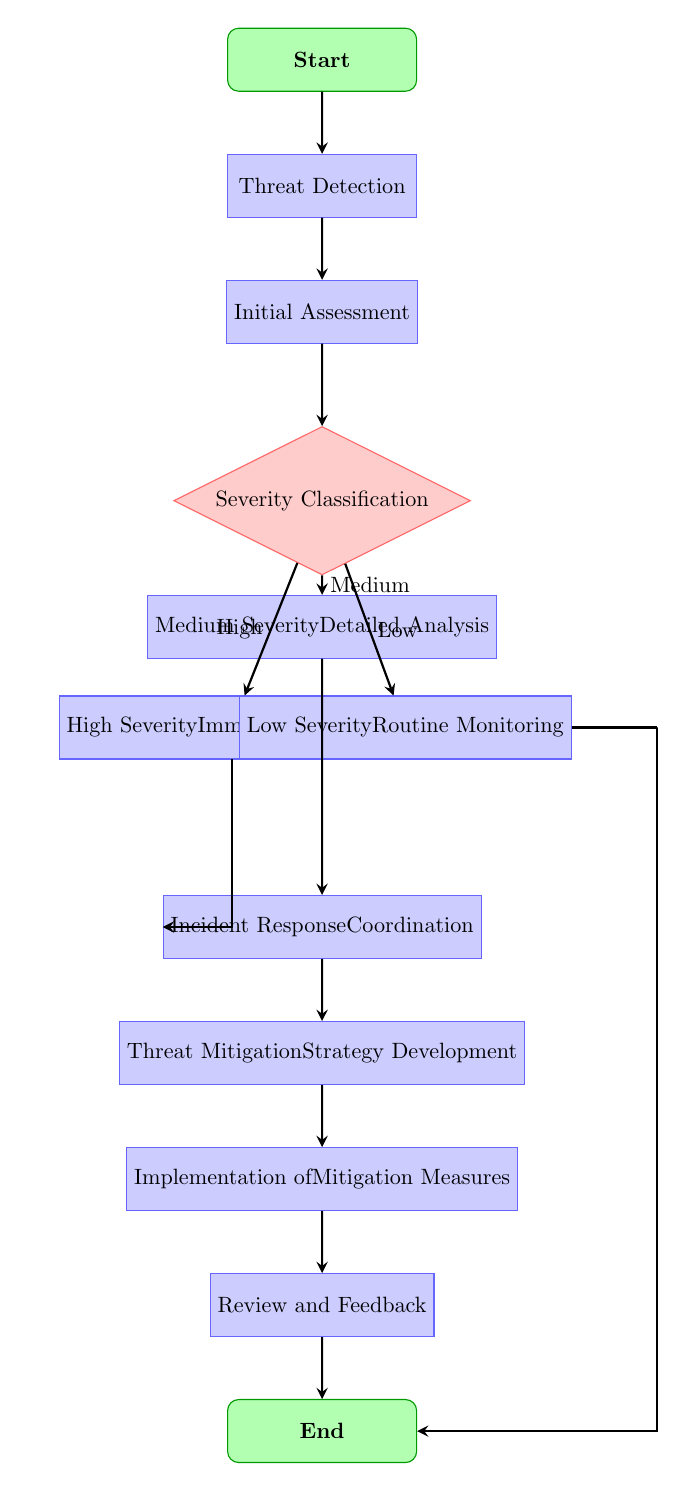What is the first step in the workflow? The first step in the workflow is labeled as “Start,” indicating the initiation of the process. This is the topmost node in the flow chart.
Answer: Start How many decision nodes are in the diagram? There is one decision node in the diagram, which is the “Severity Classification” node that has three options: High, Medium, and Low.
Answer: 1 What follows the Initial Assessment step? Following the “Initial Assessment” step, the next step is “Severity Classification,” which is a decision-making process that determines the level of severity of the detected threat.
Answer: Severity Classification If a threat is classified as Medium severity, what is the next step? If the severity classification is Medium, the workflow flows into the "Medium Severity - Detailed Analysis" process, which is specifically stated for that classification.
Answer: Medium Severity - Detailed Analysis What are the immediate actions after identifying a High Severity threat? After identifying a High Severity threat, the workflow mandates an "Immediate Response" to address the critical nature of the threat, followed by incident response coordination.
Answer: Immediate Response What are the options available for the Severity Classification decision? The options available for the "Severity Classification" decision are High, Medium, and Low. These classifications guide subsequent actions in the workflow.
Answer: High, Medium, Low Which node follows the Incident Response Coordination step? The next node after the "Incident Response Coordination" step is "Threat Mitigation Strategy Development," indicating a progression towards formulating a response strategy.
Answer: Threat Mitigation Strategy Development What happens if a threat is classified as Low severity? If a threat is classified as Low severity, the workflow directs us to "Routine Monitoring" and then concludes with the "End" node, indicating no immediate actions are required.
Answer: Routine Monitoring What is the final node in the workflow? The final node in the workflow is labeled “End,” which signifies the conclusion of the threat assessment and mitigation process after all necessary actions have been performed.
Answer: End 